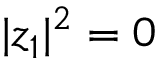<formula> <loc_0><loc_0><loc_500><loc_500>| z _ { 1 } | ^ { 2 } = 0</formula> 